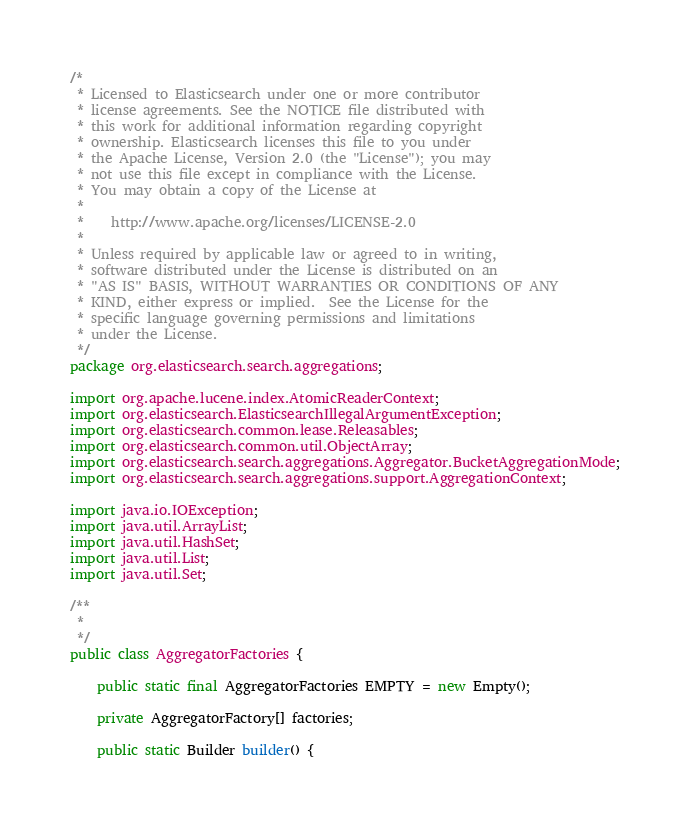Convert code to text. <code><loc_0><loc_0><loc_500><loc_500><_Java_>/*
 * Licensed to Elasticsearch under one or more contributor
 * license agreements. See the NOTICE file distributed with
 * this work for additional information regarding copyright
 * ownership. Elasticsearch licenses this file to you under
 * the Apache License, Version 2.0 (the "License"); you may
 * not use this file except in compliance with the License.
 * You may obtain a copy of the License at
 *
 *    http://www.apache.org/licenses/LICENSE-2.0
 *
 * Unless required by applicable law or agreed to in writing,
 * software distributed under the License is distributed on an
 * "AS IS" BASIS, WITHOUT WARRANTIES OR CONDITIONS OF ANY
 * KIND, either express or implied.  See the License for the
 * specific language governing permissions and limitations
 * under the License.
 */
package org.elasticsearch.search.aggregations;

import org.apache.lucene.index.AtomicReaderContext;
import org.elasticsearch.ElasticsearchIllegalArgumentException;
import org.elasticsearch.common.lease.Releasables;
import org.elasticsearch.common.util.ObjectArray;
import org.elasticsearch.search.aggregations.Aggregator.BucketAggregationMode;
import org.elasticsearch.search.aggregations.support.AggregationContext;

import java.io.IOException;
import java.util.ArrayList;
import java.util.HashSet;
import java.util.List;
import java.util.Set;

/**
 *
 */
public class AggregatorFactories {

    public static final AggregatorFactories EMPTY = new Empty();

    private AggregatorFactory[] factories;

    public static Builder builder() {</code> 